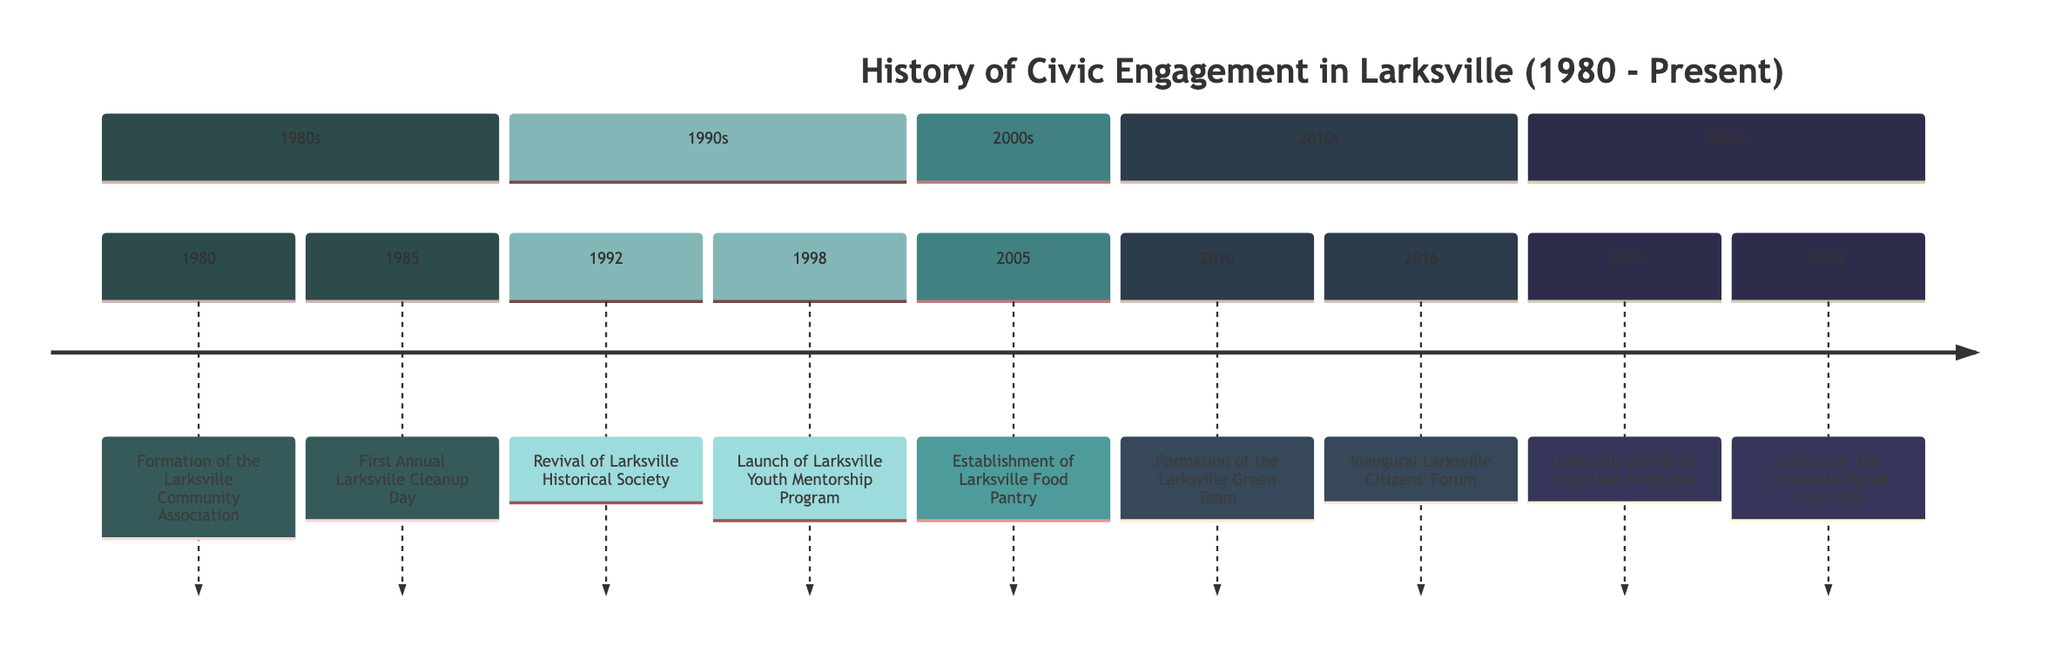What event occurred in 1985? The diagram clearly lists the events by year, and looks specifically at the year 1985, it shows that the "First Annual Larksville Cleanup Day" took place.
Answer: First Annual Larksville Cleanup Day How many significant events are listed in the timeline? By counting each event in the provided timeline, a total of 9 significant events spanning from 1980 to 2022 can be identified.
Answer: 9 What was the initiative launched in 2020? The timeline indicates that in 2020, the event "Larksville COVID-19 Volunteer Response" was launched.
Answer: Larksville COVID-19 Volunteer Response In which year was the Larksville Green Team formed? By locating the section dedicated to the 2010s in the timeline, it shows that the Larksville Green Team was formed in the year 2010.
Answer: 2010 Which two events occurred closest together in time? Analyzing the timeline for proximity, the events "Larksville COVID-19 Volunteer Response" in 2020 and "Launch of the Larksville Digital Civic Hub" in 2022 occurred closest together with only a 2-year gap between them.
Answer: Larksville COVID-19 Volunteer Response and Launch of the Larksville Digital Civic Hub What was established in 2005? Referring to the specific year 2005 in the timeline, it highlights the "Establishment of Larksville Food Pantry" as a significant event.
Answer: Establishment of Larksville Food Pantry What was the aim of the Larksville Community Association formed in 1980? The timeline specifies that the aim of the Larksville Community Association was to "foster community involvement and address local issues."
Answer: Foster community involvement and address local issues How many events are listed in the 1990s section? By inspecting the timeline, it shows that there are two events in the 1990s section: "Revival of Larksville Historical Society" (1992) and "Launch of Larksville Youth Mentorship Program" (1998).
Answer: 2 What does the Larksville Digital Civic Hub allow residents to do? The description in the timeline states that the Larksville Digital Civic Hub was launched to allow residents to "stay informed about local governance, participate in virtual town halls, and volunteer for community projects."
Answer: Stay informed about local governance, participate in virtual town halls, and volunteer for community projects 